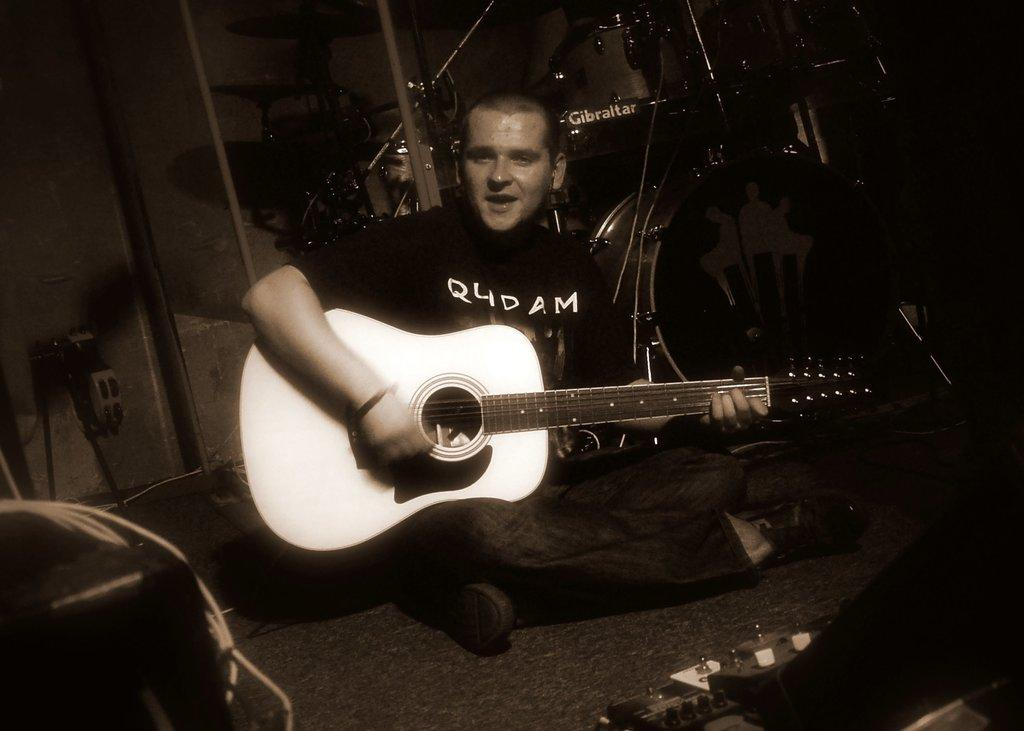What is the main subject of the image? There is a person in the image. What is the person doing in the image? The person is sitting. What object is the person holding in the image? The person is holding a guitar. What color scheme is used in the image? The image is in black and white color. Can you see the person jumping on a bike in the image? No, there is no person jumping on a bike in the image. The person is sitting and holding a guitar, and the image is in black and white color. 